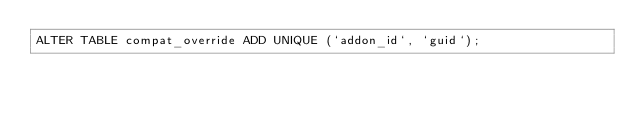<code> <loc_0><loc_0><loc_500><loc_500><_SQL_>ALTER TABLE compat_override ADD UNIQUE (`addon_id`, `guid`);
</code> 